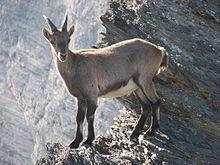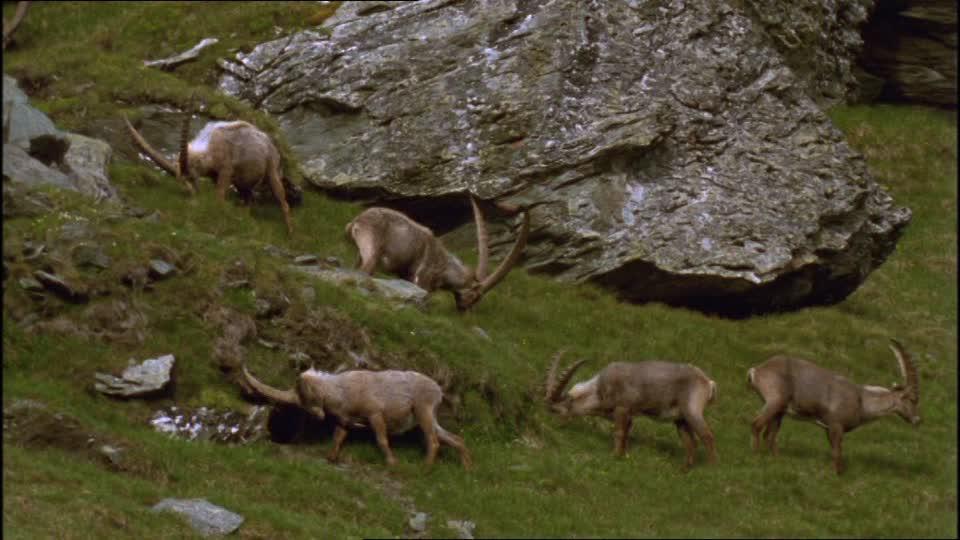The first image is the image on the left, the second image is the image on the right. Given the left and right images, does the statement "An image contains only a rightward-facing horned animal in a pose on green grass." hold true? Answer yes or no. No. The first image is the image on the left, the second image is the image on the right. For the images displayed, is the sentence "A single animal is standing in the grass in the image on the left." factually correct? Answer yes or no. No. 